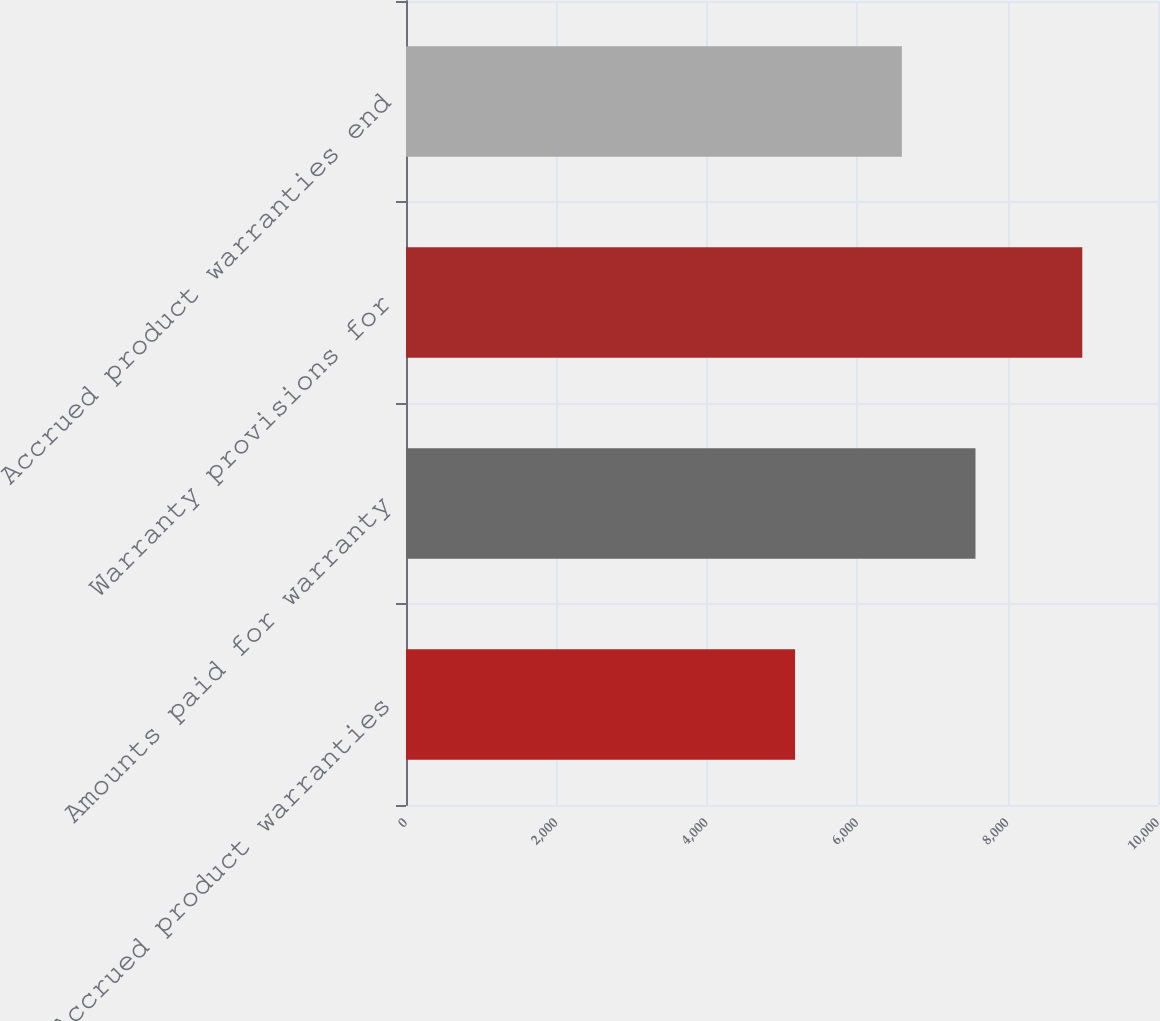Convert chart. <chart><loc_0><loc_0><loc_500><loc_500><bar_chart><fcel>Accrued product warranties<fcel>Amounts paid for warranty<fcel>Warranty provisions for<fcel>Accrued product warranties end<nl><fcel>5174<fcel>7573<fcel>8993<fcel>6594<nl></chart> 